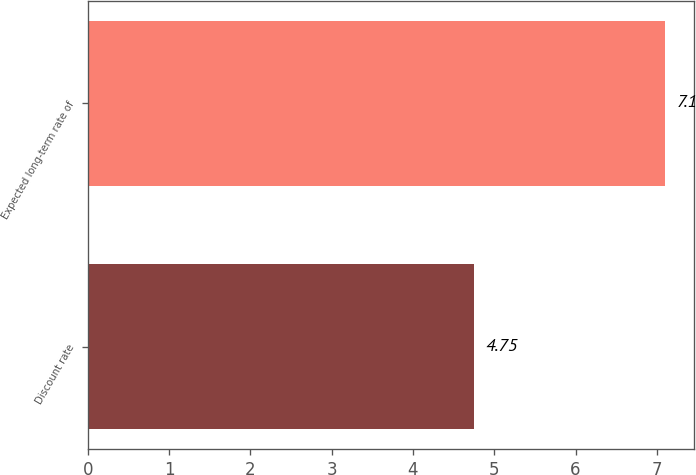Convert chart. <chart><loc_0><loc_0><loc_500><loc_500><bar_chart><fcel>Discount rate<fcel>Expected long-term rate of<nl><fcel>4.75<fcel>7.1<nl></chart> 